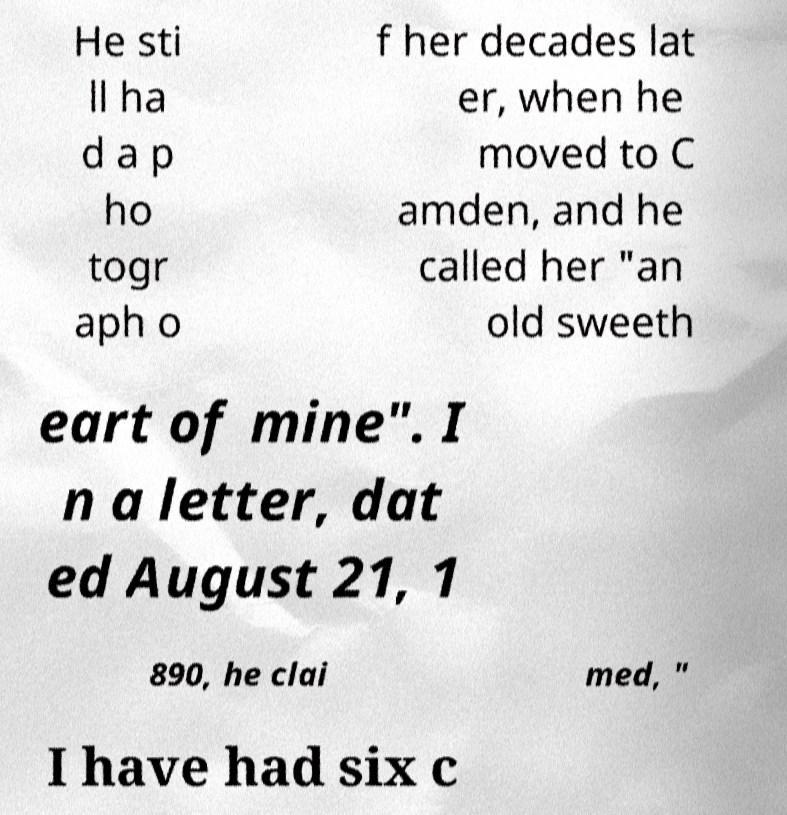What messages or text are displayed in this image? I need them in a readable, typed format. He sti ll ha d a p ho togr aph o f her decades lat er, when he moved to C amden, and he called her "an old sweeth eart of mine". I n a letter, dat ed August 21, 1 890, he clai med, " I have had six c 